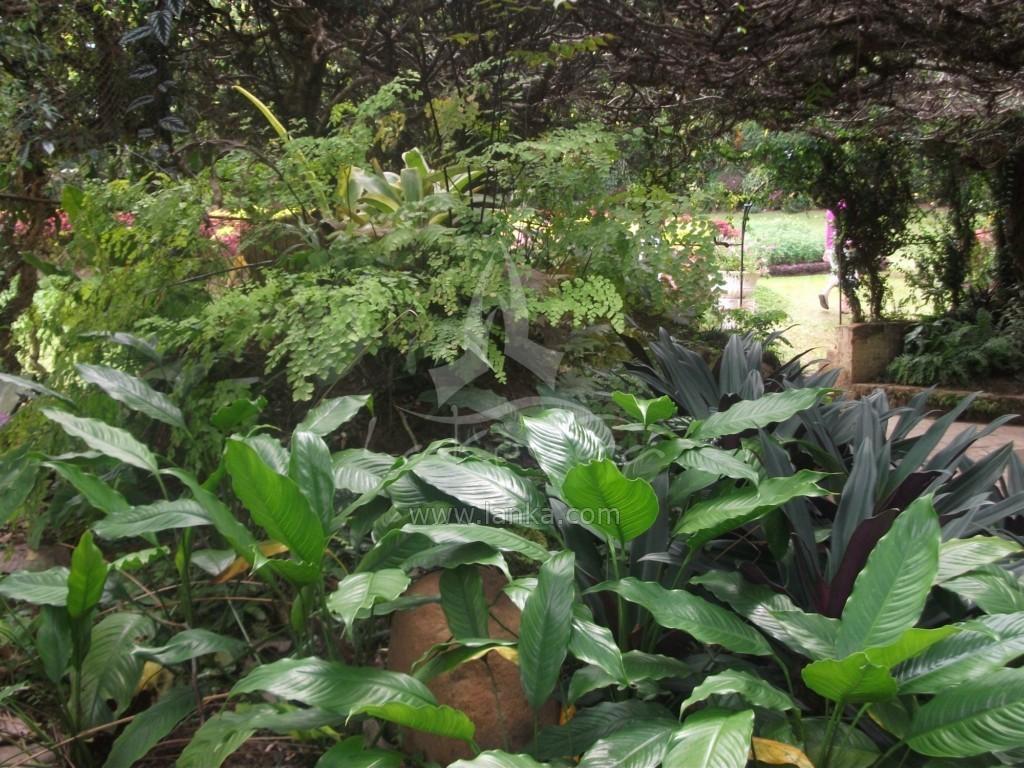Describe this image in one or two sentences. In the foreground of the picture I can see the plants. There is a person walking on the grass on the right side. In the background, I can see the trees. 